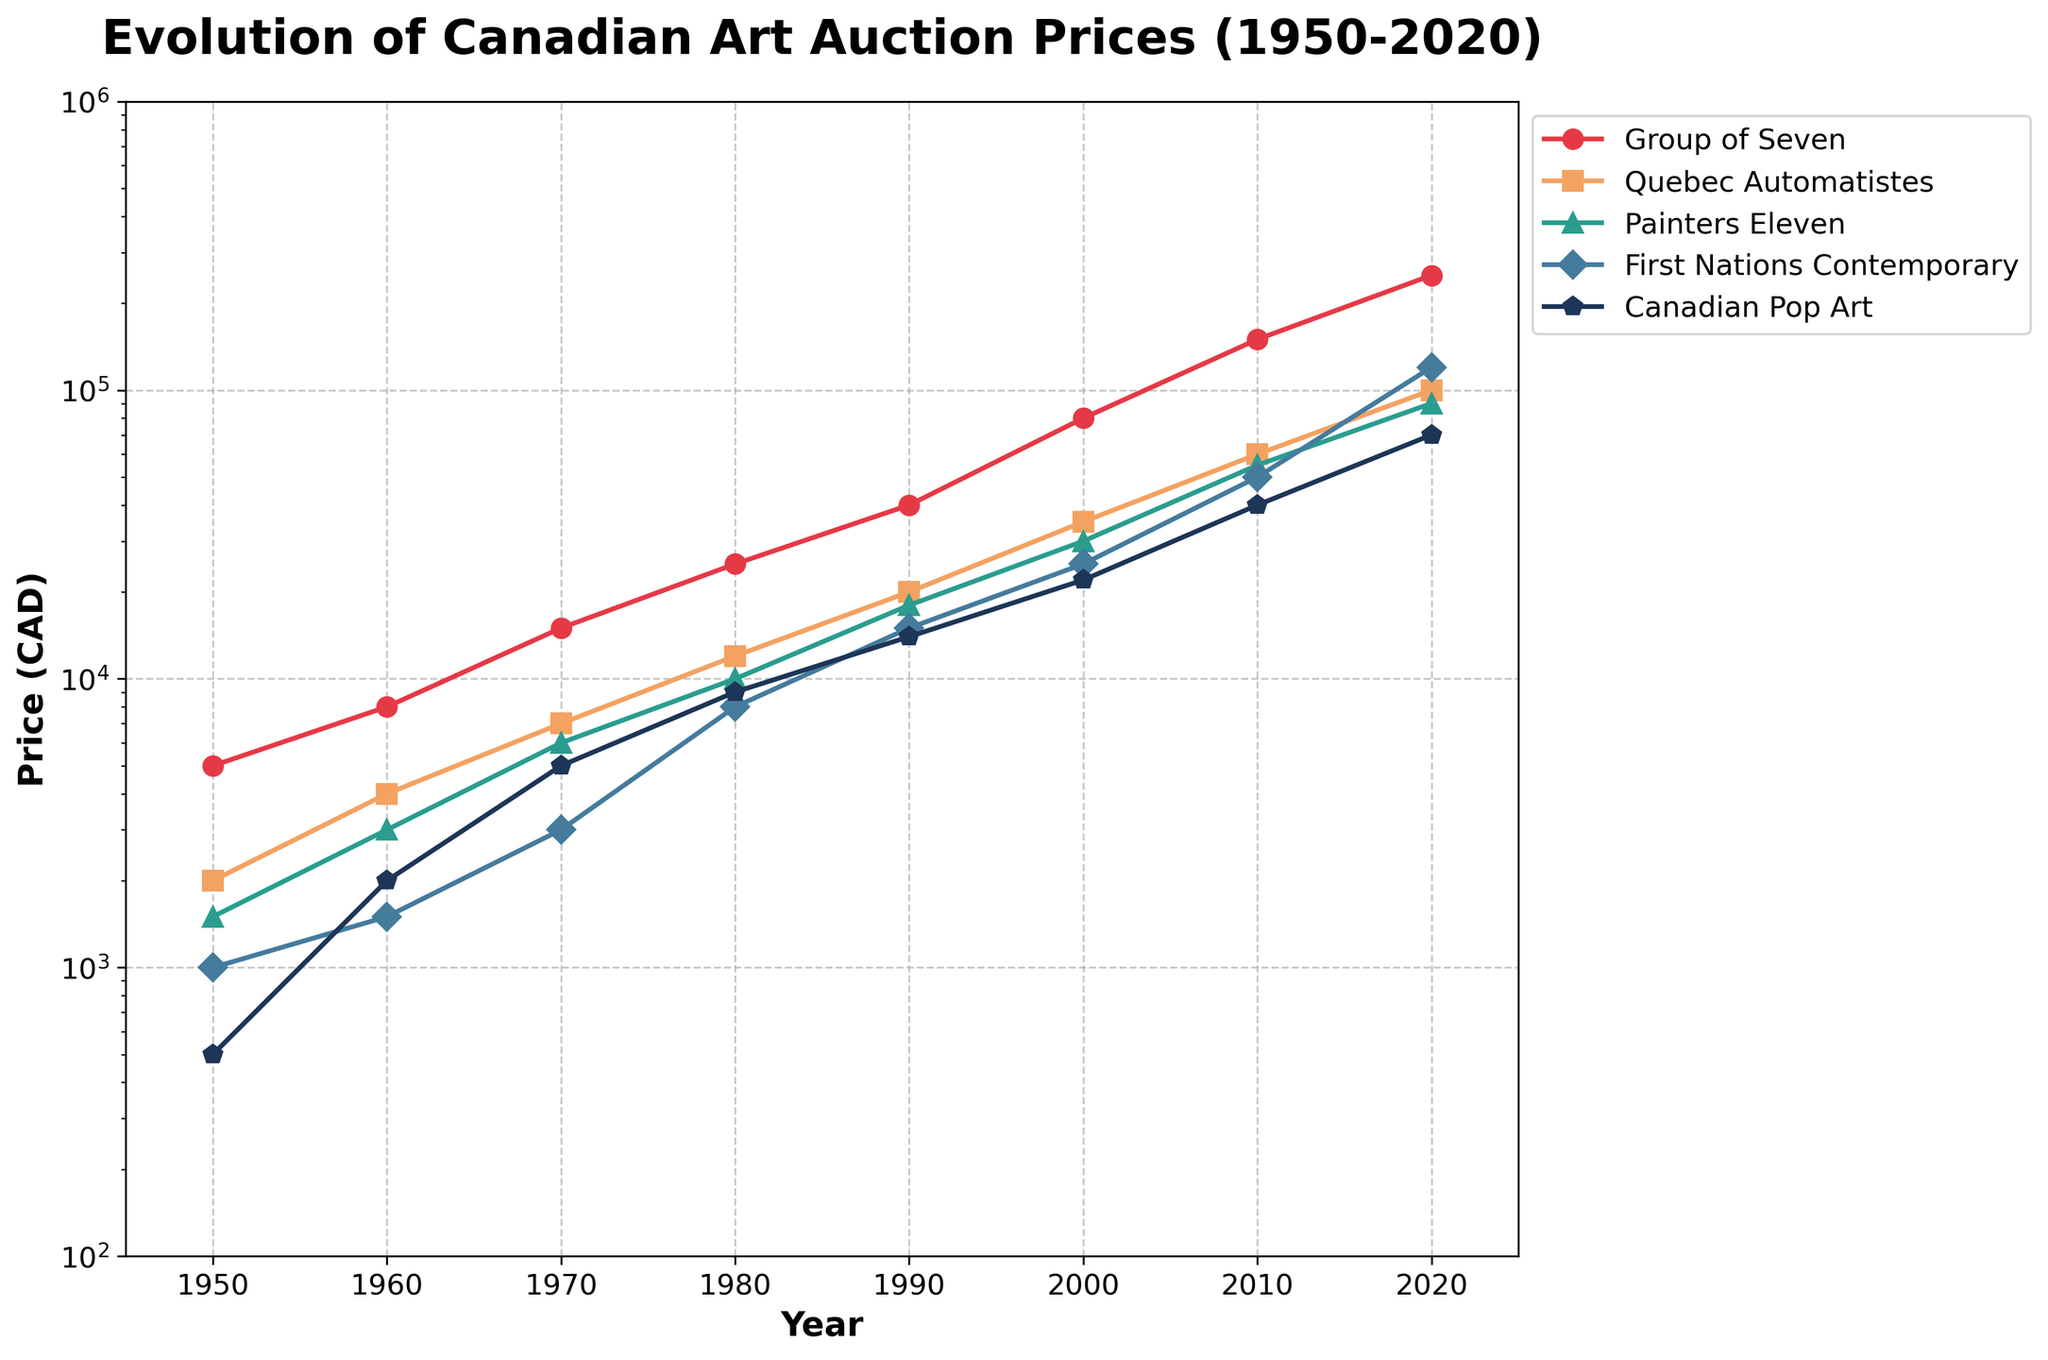What is the title of the figure? The title is usually located at the top of the figure. In this case, it reads "Evolution of Canadian Art Auction Prices (1950-2020)"
Answer: Evolution of Canadian Art Auction Prices (1950-2020) What are the five artistic movements shown in the figure? The legend on the right side of the figure lists these artistic movements. The five movements are Group of Seven, Quebec Automatistes, Painters Eleven, First Nations Contemporary, and Canadian Pop Art
Answer: Group of Seven, Quebec Automatistes, Painters Eleven, First Nations Contemporary, Canadian Pop Art Which artistic movement had the highest auction prices in 2020? Examining the endpoints of the lines in the year 2020, the Group of Seven line reaches the highest price level among all movements
Answer: Group of Seven What is the trend in auction prices for First Nations Contemporary from 1950 to 2020? Observing the line representing First Nations Contemporary, it shows a continuous upward trend from 1000 CAD in 1950 to about 120000 CAD in 2020
Answer: Continuous upward trend How does the price of Quebec Automatistes in 1980 compare to that of Canadian Pop Art in 1980? The point in 1980 for Quebec Automatistes is around 12000 CAD, while Canadian Pop Art in 1980 is at about 9000 CAD. Thus, Quebec Automatistes is higher
Answer: Quebec Automatistes is higher Which artistic movement saw the largest increase in auction prices between 1950 and 2020? The difference between the 2020 and 1950 points is greatest for Group of Seven, which increased from 5000 CAD to 250000 CAD
Answer: Group of Seven What's the average auction price of Painters Eleven in 2000 and 2010? The prices for Painters Eleven in 2000 and 2010 are 30000 CAD and 55000 CAD respectively. The average is (30000 + 55000) / 2 = 42500 CAD
Answer: 42500 CAD What is the median auction price of Quebec Automatistes across all years shown? The prices for Quebec Automatistes over the years are 2000, 4000, 7000, 12000, 20000, 35000, 60000, and 100000 CAD. Sorting these values gives 2000, 4000, 7000, 12000, 20000, 35000, 60000, and 100000. The median is the average of the 4th and 5th values: (12000 + 20000) / 2 = 16000 CAD
Answer: 16000 CAD By how much did the price of Canadian Pop Art increase from 1960 to 2020? In 1960, the auction price was 2000 CAD, and in 2020 it was 70000 CAD. Therefore, the increase is 70000 - 2000 = 68000 CAD
Answer: 68000 CAD Which artistic movement was valued less than 10000 CAD in 1980? Observing the plots, Painters Eleven and Canadian Pop Art were valued at approximately 10000 CAD and 9000 CAD respectively in 1980. However, Canadian Pop Art is explicitly below 10000 CAD
Answer: Canadian Pop Art 